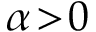Convert formula to latex. <formula><loc_0><loc_0><loc_500><loc_500>\alpha \, > \, 0</formula> 